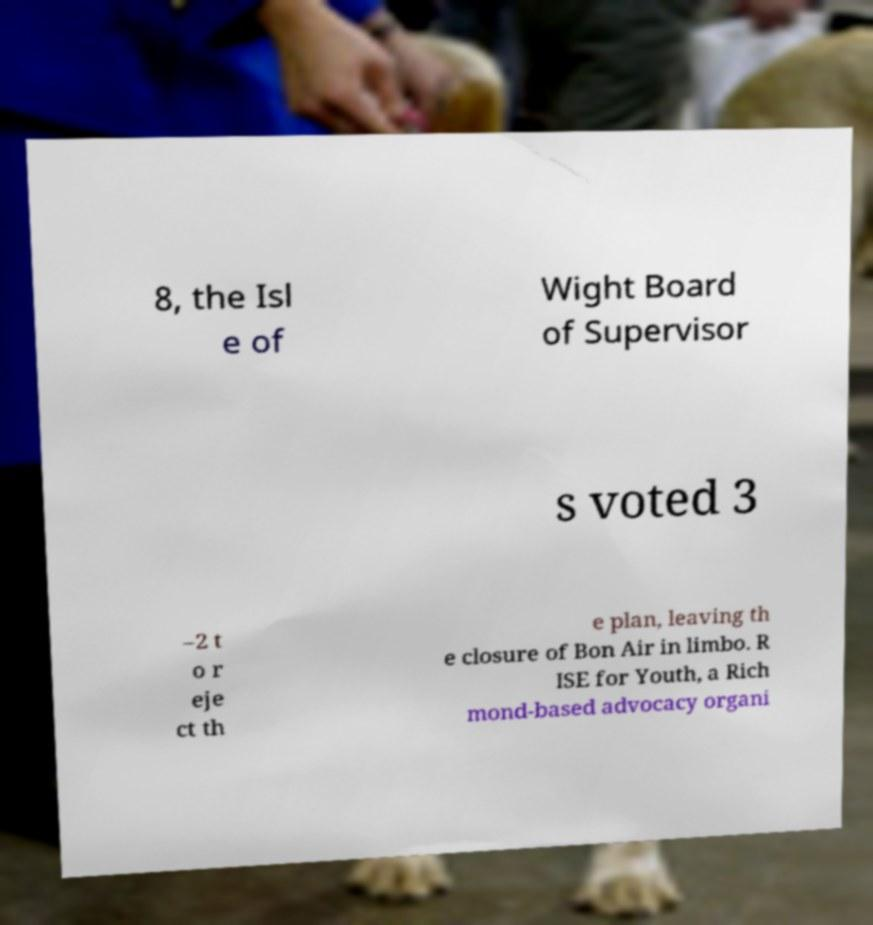There's text embedded in this image that I need extracted. Can you transcribe it verbatim? 8, the Isl e of Wight Board of Supervisor s voted 3 –2 t o r eje ct th e plan, leaving th e closure of Bon Air in limbo. R ISE for Youth, a Rich mond-based advocacy organi 